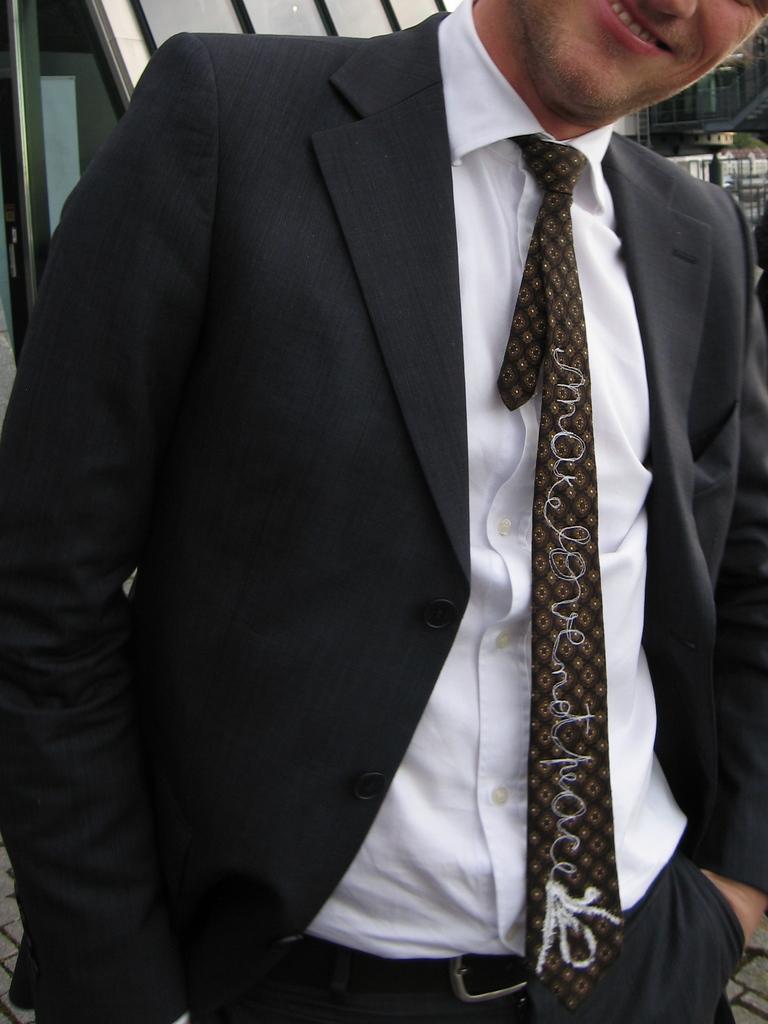Can you describe this image briefly? In this image I can see the person is wearing black and white color dress and the tie. Back I can see few objects. 